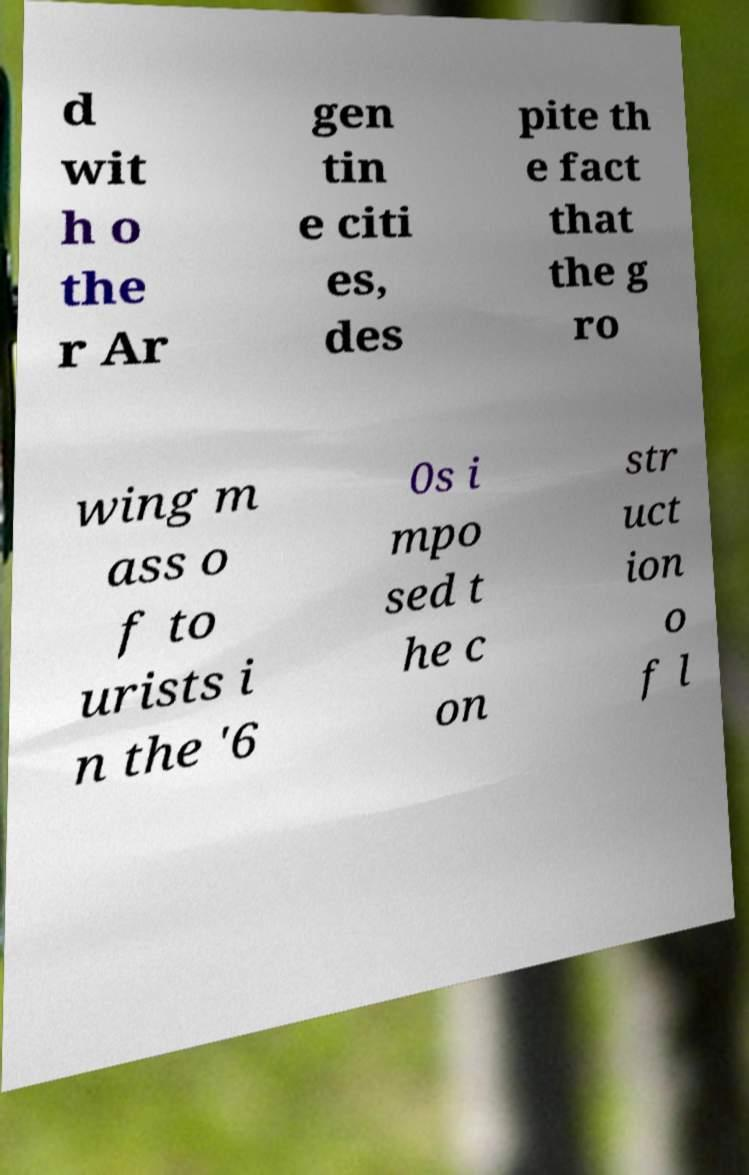Please identify and transcribe the text found in this image. d wit h o the r Ar gen tin e citi es, des pite th e fact that the g ro wing m ass o f to urists i n the '6 0s i mpo sed t he c on str uct ion o f l 